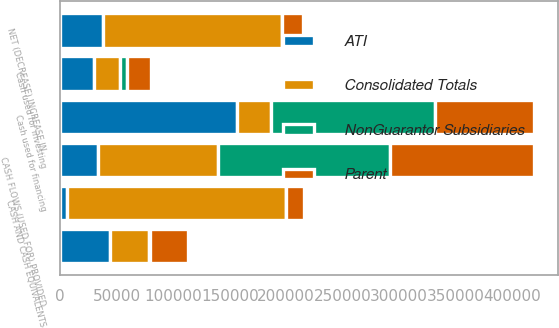Convert chart. <chart><loc_0><loc_0><loc_500><loc_500><stacked_bar_chart><ecel><fcel>CASH FLOWS (USED FOR) PROVIDED<fcel>Cash used for investing<fcel>Cash used for financing<fcel>NET (DECREASE) INCREASE IN<fcel>CASH AND CASH EQUIVALENTS<fcel>Unnamed: 6<nl><fcel>Consolidated Totals<fcel>106391<fcel>22349<fcel>29733<fcel>158473<fcel>193483<fcel>35010<nl><fcel>ATI<fcel>33608<fcel>30278<fcel>156447<fcel>37799<fcel>6174<fcel>43973<nl><fcel>NonGuarantor Subsidiaries<fcel>152008<fcel>6587<fcel>145618<fcel>197<fcel>307<fcel>110<nl><fcel>Parent<fcel>127063<fcel>21320<fcel>87728<fcel>18015<fcel>15593<fcel>33608<nl></chart> 